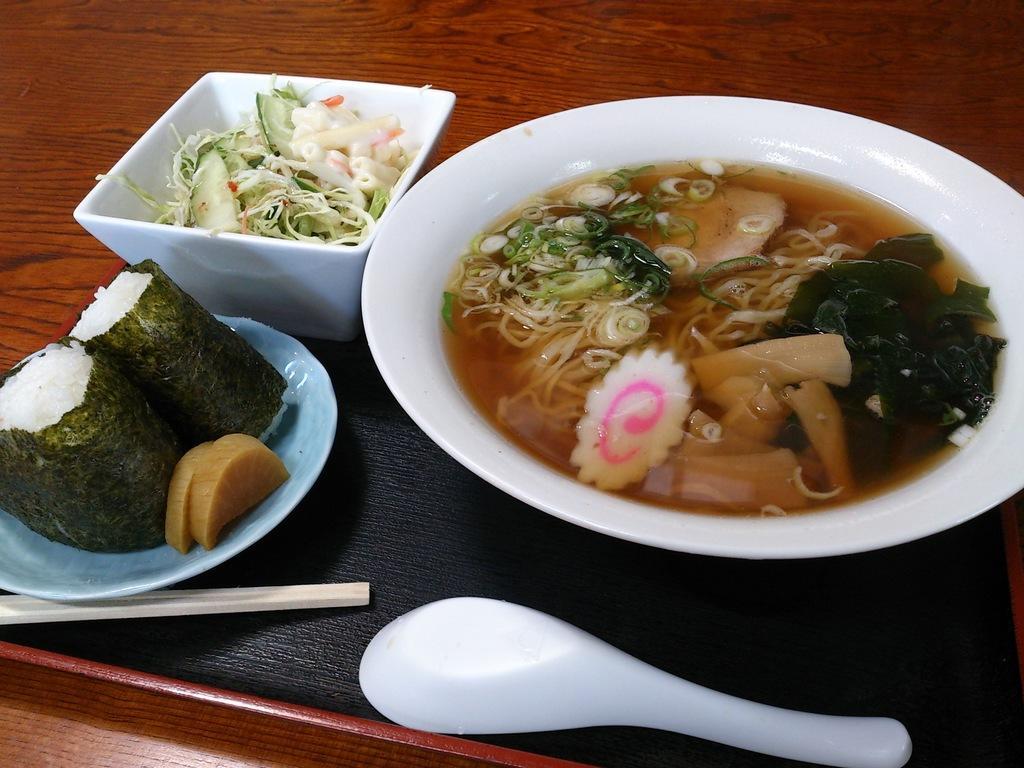Describe this image in one or two sentences. On this wooden table we can able to see plates, tray, chopsticks, spoon, bowl and food. 